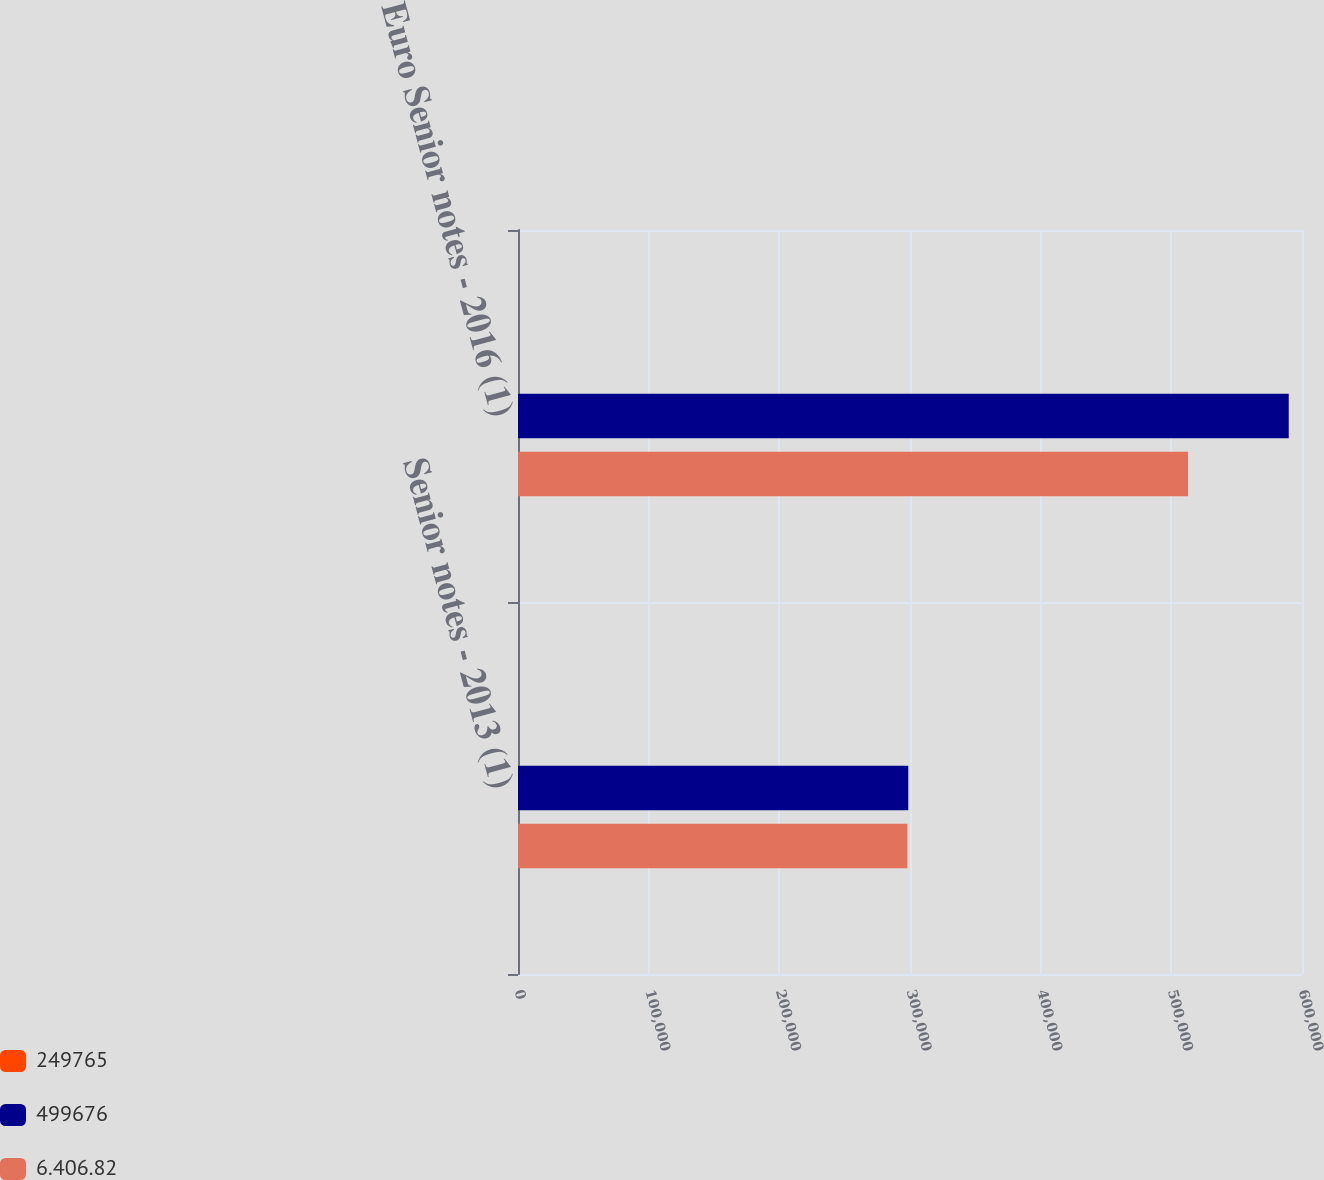Convert chart to OTSL. <chart><loc_0><loc_0><loc_500><loc_500><stacked_bar_chart><ecel><fcel>Senior notes - 2013 (1)<fcel>Euro Senior notes - 2016 (1)<nl><fcel>249765<fcel>3.39<fcel>1.99<nl><fcel>499676<fcel>298670<fcel>589848<nl><fcel>6.406.82<fcel>297986<fcel>512764<nl></chart> 